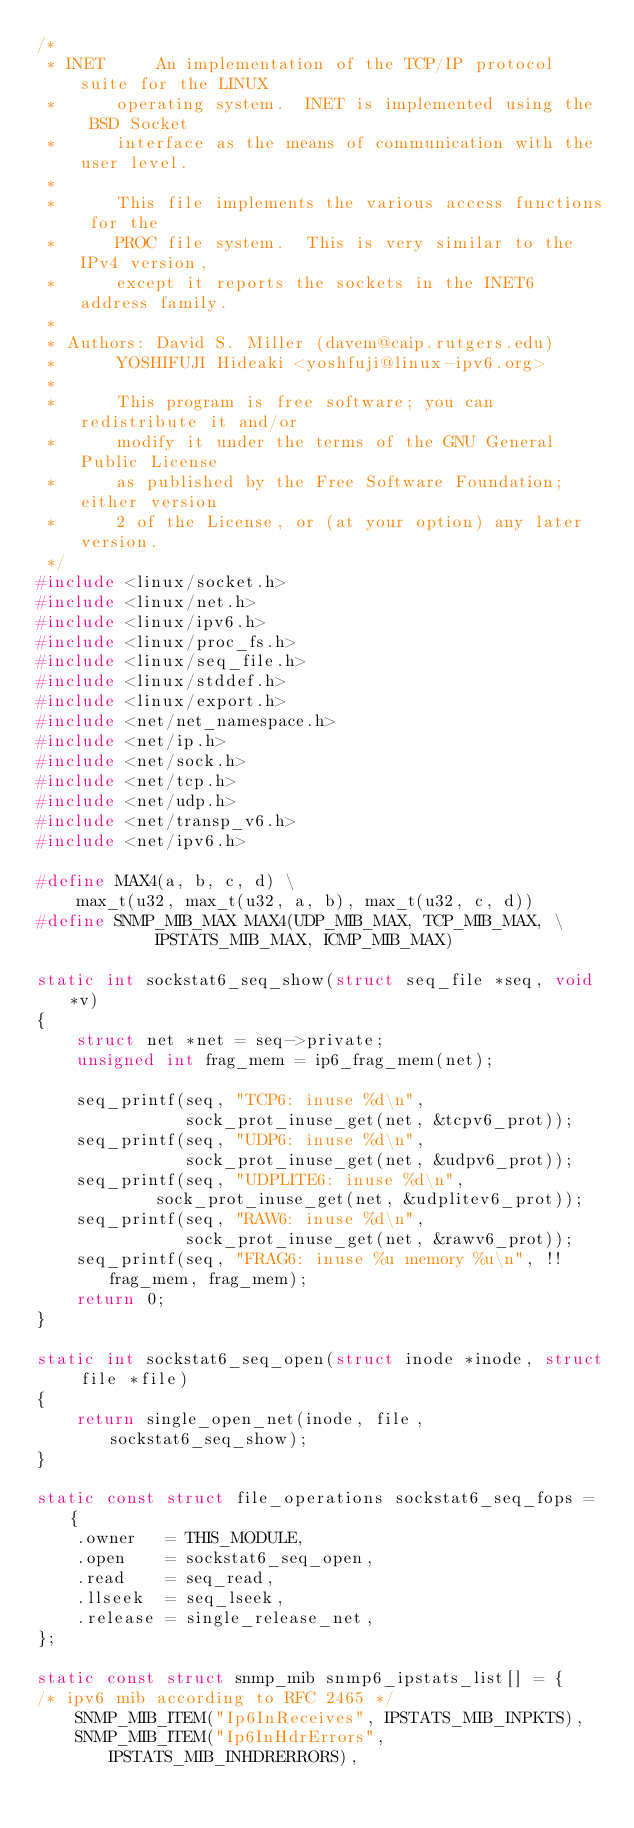<code> <loc_0><loc_0><loc_500><loc_500><_C_>/*
 * INET		An implementation of the TCP/IP protocol suite for the LINUX
 *		operating system.  INET is implemented using the  BSD Socket
 *		interface as the means of communication with the user level.
 *
 *		This file implements the various access functions for the
 *		PROC file system.  This is very similar to the IPv4 version,
 *		except it reports the sockets in the INET6 address family.
 *
 * Authors:	David S. Miller (davem@caip.rutgers.edu)
 *		YOSHIFUJI Hideaki <yoshfuji@linux-ipv6.org>
 *
 *		This program is free software; you can redistribute it and/or
 *		modify it under the terms of the GNU General Public License
 *		as published by the Free Software Foundation; either version
 *		2 of the License, or (at your option) any later version.
 */
#include <linux/socket.h>
#include <linux/net.h>
#include <linux/ipv6.h>
#include <linux/proc_fs.h>
#include <linux/seq_file.h>
#include <linux/stddef.h>
#include <linux/export.h>
#include <net/net_namespace.h>
#include <net/ip.h>
#include <net/sock.h>
#include <net/tcp.h>
#include <net/udp.h>
#include <net/transp_v6.h>
#include <net/ipv6.h>

#define MAX4(a, b, c, d) \
	max_t(u32, max_t(u32, a, b), max_t(u32, c, d))
#define SNMP_MIB_MAX MAX4(UDP_MIB_MAX, TCP_MIB_MAX, \
			IPSTATS_MIB_MAX, ICMP_MIB_MAX)

static int sockstat6_seq_show(struct seq_file *seq, void *v)
{
	struct net *net = seq->private;
	unsigned int frag_mem = ip6_frag_mem(net);

	seq_printf(seq, "TCP6: inuse %d\n",
		       sock_prot_inuse_get(net, &tcpv6_prot));
	seq_printf(seq, "UDP6: inuse %d\n",
		       sock_prot_inuse_get(net, &udpv6_prot));
	seq_printf(seq, "UDPLITE6: inuse %d\n",
			sock_prot_inuse_get(net, &udplitev6_prot));
	seq_printf(seq, "RAW6: inuse %d\n",
		       sock_prot_inuse_get(net, &rawv6_prot));
	seq_printf(seq, "FRAG6: inuse %u memory %u\n", !!frag_mem, frag_mem);
	return 0;
}

static int sockstat6_seq_open(struct inode *inode, struct file *file)
{
	return single_open_net(inode, file, sockstat6_seq_show);
}

static const struct file_operations sockstat6_seq_fops = {
	.owner	 = THIS_MODULE,
	.open	 = sockstat6_seq_open,
	.read	 = seq_read,
	.llseek	 = seq_lseek,
	.release = single_release_net,
};

static const struct snmp_mib snmp6_ipstats_list[] = {
/* ipv6 mib according to RFC 2465 */
	SNMP_MIB_ITEM("Ip6InReceives", IPSTATS_MIB_INPKTS),
	SNMP_MIB_ITEM("Ip6InHdrErrors", IPSTATS_MIB_INHDRERRORS),</code> 